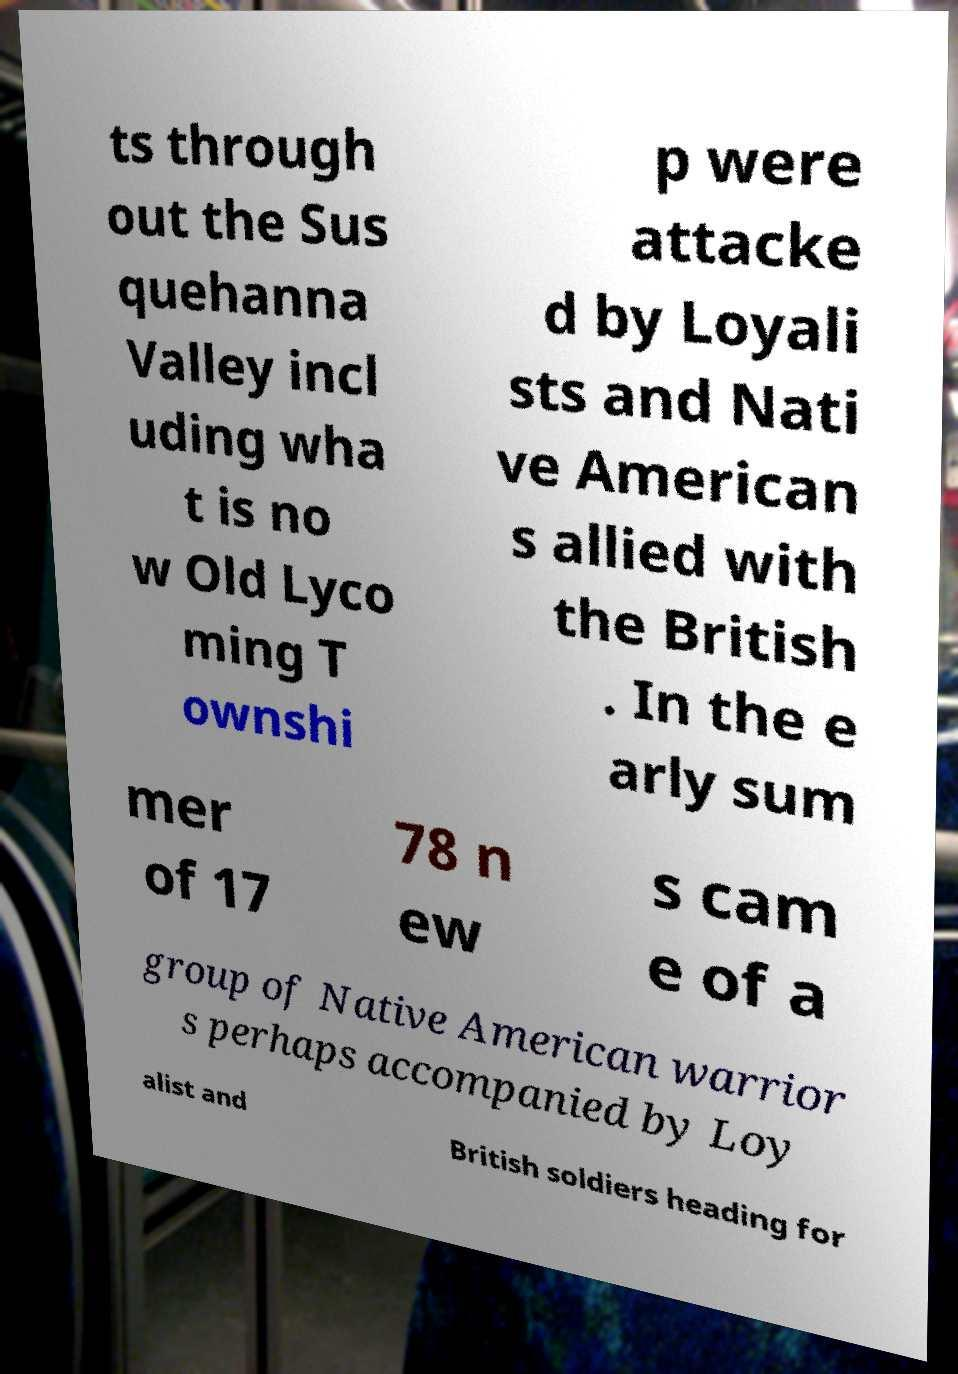Could you assist in decoding the text presented in this image and type it out clearly? ts through out the Sus quehanna Valley incl uding wha t is no w Old Lyco ming T ownshi p were attacke d by Loyali sts and Nati ve American s allied with the British . In the e arly sum mer of 17 78 n ew s cam e of a group of Native American warrior s perhaps accompanied by Loy alist and British soldiers heading for 